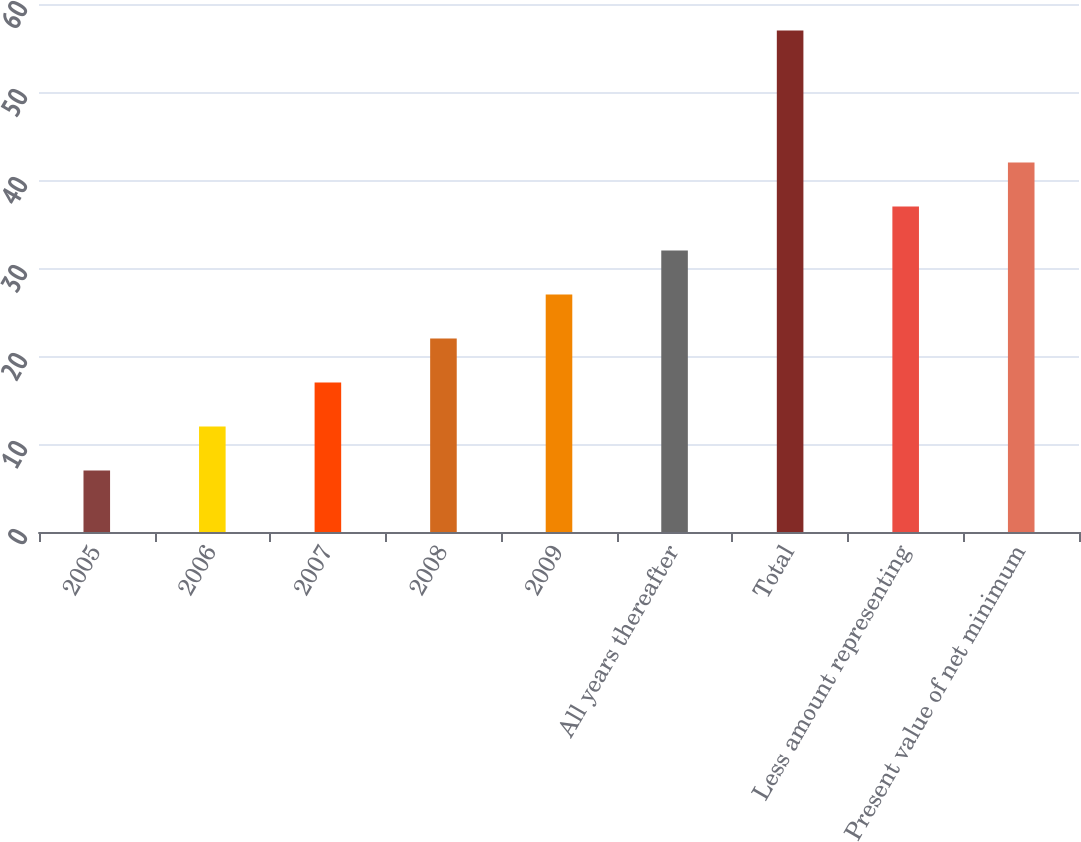Convert chart. <chart><loc_0><loc_0><loc_500><loc_500><bar_chart><fcel>2005<fcel>2006<fcel>2007<fcel>2008<fcel>2009<fcel>All years thereafter<fcel>Total<fcel>Less amount representing<fcel>Present value of net minimum<nl><fcel>7<fcel>12<fcel>17<fcel>22<fcel>27<fcel>32<fcel>57<fcel>37<fcel>42<nl></chart> 